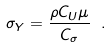<formula> <loc_0><loc_0><loc_500><loc_500>\sigma _ { Y } = \frac { \rho C _ { U } \mu } { C _ { \sigma } } \ .</formula> 